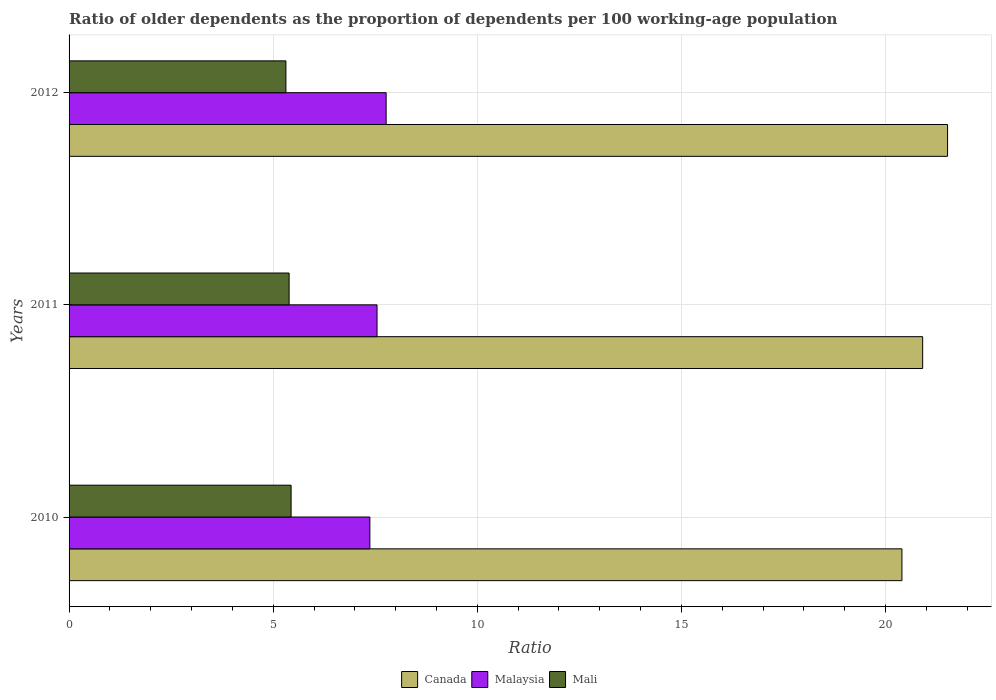How many different coloured bars are there?
Your answer should be very brief. 3. How many groups of bars are there?
Provide a short and direct response. 3. Are the number of bars on each tick of the Y-axis equal?
Provide a succinct answer. Yes. How many bars are there on the 3rd tick from the top?
Make the answer very short. 3. How many bars are there on the 3rd tick from the bottom?
Offer a terse response. 3. What is the label of the 1st group of bars from the top?
Your answer should be very brief. 2012. What is the age dependency ratio(old) in Malaysia in 2012?
Offer a terse response. 7.77. Across all years, what is the maximum age dependency ratio(old) in Mali?
Give a very brief answer. 5.44. Across all years, what is the minimum age dependency ratio(old) in Mali?
Offer a terse response. 5.31. In which year was the age dependency ratio(old) in Canada maximum?
Keep it short and to the point. 2012. In which year was the age dependency ratio(old) in Canada minimum?
Your answer should be very brief. 2010. What is the total age dependency ratio(old) in Mali in the graph?
Offer a terse response. 16.14. What is the difference between the age dependency ratio(old) in Mali in 2010 and that in 2011?
Offer a very short reply. 0.05. What is the difference between the age dependency ratio(old) in Malaysia in 2010 and the age dependency ratio(old) in Canada in 2011?
Provide a succinct answer. -13.54. What is the average age dependency ratio(old) in Malaysia per year?
Offer a very short reply. 7.56. In the year 2012, what is the difference between the age dependency ratio(old) in Canada and age dependency ratio(old) in Malaysia?
Keep it short and to the point. 13.75. What is the ratio of the age dependency ratio(old) in Malaysia in 2010 to that in 2011?
Offer a terse response. 0.98. Is the age dependency ratio(old) in Mali in 2010 less than that in 2012?
Your answer should be compact. No. What is the difference between the highest and the second highest age dependency ratio(old) in Canada?
Your answer should be compact. 0.61. What is the difference between the highest and the lowest age dependency ratio(old) in Malaysia?
Make the answer very short. 0.4. What does the 3rd bar from the bottom in 2011 represents?
Provide a short and direct response. Mali. How many bars are there?
Your answer should be very brief. 9. Are all the bars in the graph horizontal?
Make the answer very short. Yes. How many legend labels are there?
Provide a short and direct response. 3. How are the legend labels stacked?
Your answer should be very brief. Horizontal. What is the title of the graph?
Offer a terse response. Ratio of older dependents as the proportion of dependents per 100 working-age population. Does "Bhutan" appear as one of the legend labels in the graph?
Provide a succinct answer. No. What is the label or title of the X-axis?
Your response must be concise. Ratio. What is the label or title of the Y-axis?
Provide a succinct answer. Years. What is the Ratio in Canada in 2010?
Give a very brief answer. 20.4. What is the Ratio in Malaysia in 2010?
Provide a succinct answer. 7.37. What is the Ratio of Mali in 2010?
Provide a succinct answer. 5.44. What is the Ratio of Canada in 2011?
Your response must be concise. 20.91. What is the Ratio in Malaysia in 2011?
Make the answer very short. 7.54. What is the Ratio in Mali in 2011?
Offer a very short reply. 5.39. What is the Ratio in Canada in 2012?
Your response must be concise. 21.52. What is the Ratio in Malaysia in 2012?
Provide a succinct answer. 7.77. What is the Ratio in Mali in 2012?
Offer a very short reply. 5.31. Across all years, what is the maximum Ratio of Canada?
Offer a very short reply. 21.52. Across all years, what is the maximum Ratio of Malaysia?
Ensure brevity in your answer.  7.77. Across all years, what is the maximum Ratio of Mali?
Your answer should be compact. 5.44. Across all years, what is the minimum Ratio of Canada?
Provide a succinct answer. 20.4. Across all years, what is the minimum Ratio of Malaysia?
Make the answer very short. 7.37. Across all years, what is the minimum Ratio of Mali?
Offer a terse response. 5.31. What is the total Ratio in Canada in the graph?
Offer a terse response. 62.83. What is the total Ratio in Malaysia in the graph?
Keep it short and to the point. 22.68. What is the total Ratio of Mali in the graph?
Provide a succinct answer. 16.14. What is the difference between the Ratio in Canada in 2010 and that in 2011?
Ensure brevity in your answer.  -0.51. What is the difference between the Ratio in Malaysia in 2010 and that in 2011?
Provide a succinct answer. -0.18. What is the difference between the Ratio of Mali in 2010 and that in 2011?
Your response must be concise. 0.05. What is the difference between the Ratio in Canada in 2010 and that in 2012?
Give a very brief answer. -1.12. What is the difference between the Ratio in Malaysia in 2010 and that in 2012?
Your answer should be compact. -0.4. What is the difference between the Ratio in Mali in 2010 and that in 2012?
Your response must be concise. 0.13. What is the difference between the Ratio in Canada in 2011 and that in 2012?
Give a very brief answer. -0.61. What is the difference between the Ratio of Malaysia in 2011 and that in 2012?
Give a very brief answer. -0.22. What is the difference between the Ratio of Mali in 2011 and that in 2012?
Ensure brevity in your answer.  0.08. What is the difference between the Ratio of Canada in 2010 and the Ratio of Malaysia in 2011?
Make the answer very short. 12.86. What is the difference between the Ratio in Canada in 2010 and the Ratio in Mali in 2011?
Your answer should be compact. 15.01. What is the difference between the Ratio of Malaysia in 2010 and the Ratio of Mali in 2011?
Your response must be concise. 1.98. What is the difference between the Ratio of Canada in 2010 and the Ratio of Malaysia in 2012?
Your response must be concise. 12.63. What is the difference between the Ratio in Canada in 2010 and the Ratio in Mali in 2012?
Offer a very short reply. 15.09. What is the difference between the Ratio of Malaysia in 2010 and the Ratio of Mali in 2012?
Offer a very short reply. 2.06. What is the difference between the Ratio in Canada in 2011 and the Ratio in Malaysia in 2012?
Offer a terse response. 13.14. What is the difference between the Ratio of Canada in 2011 and the Ratio of Mali in 2012?
Your response must be concise. 15.6. What is the difference between the Ratio of Malaysia in 2011 and the Ratio of Mali in 2012?
Make the answer very short. 2.23. What is the average Ratio in Canada per year?
Provide a short and direct response. 20.94. What is the average Ratio of Malaysia per year?
Provide a succinct answer. 7.56. What is the average Ratio of Mali per year?
Give a very brief answer. 5.38. In the year 2010, what is the difference between the Ratio of Canada and Ratio of Malaysia?
Your answer should be very brief. 13.03. In the year 2010, what is the difference between the Ratio of Canada and Ratio of Mali?
Ensure brevity in your answer.  14.96. In the year 2010, what is the difference between the Ratio of Malaysia and Ratio of Mali?
Your response must be concise. 1.93. In the year 2011, what is the difference between the Ratio of Canada and Ratio of Malaysia?
Keep it short and to the point. 13.37. In the year 2011, what is the difference between the Ratio in Canada and Ratio in Mali?
Provide a short and direct response. 15.52. In the year 2011, what is the difference between the Ratio of Malaysia and Ratio of Mali?
Your answer should be very brief. 2.15. In the year 2012, what is the difference between the Ratio in Canada and Ratio in Malaysia?
Give a very brief answer. 13.75. In the year 2012, what is the difference between the Ratio in Canada and Ratio in Mali?
Your answer should be very brief. 16.21. In the year 2012, what is the difference between the Ratio of Malaysia and Ratio of Mali?
Provide a succinct answer. 2.46. What is the ratio of the Ratio of Canada in 2010 to that in 2011?
Ensure brevity in your answer.  0.98. What is the ratio of the Ratio of Malaysia in 2010 to that in 2011?
Offer a very short reply. 0.98. What is the ratio of the Ratio of Mali in 2010 to that in 2011?
Offer a terse response. 1.01. What is the ratio of the Ratio in Canada in 2010 to that in 2012?
Ensure brevity in your answer.  0.95. What is the ratio of the Ratio of Malaysia in 2010 to that in 2012?
Offer a terse response. 0.95. What is the ratio of the Ratio in Mali in 2010 to that in 2012?
Your answer should be very brief. 1.02. What is the ratio of the Ratio in Canada in 2011 to that in 2012?
Offer a very short reply. 0.97. What is the ratio of the Ratio in Malaysia in 2011 to that in 2012?
Make the answer very short. 0.97. What is the ratio of the Ratio of Mali in 2011 to that in 2012?
Provide a succinct answer. 1.01. What is the difference between the highest and the second highest Ratio in Canada?
Provide a short and direct response. 0.61. What is the difference between the highest and the second highest Ratio in Malaysia?
Keep it short and to the point. 0.22. What is the difference between the highest and the second highest Ratio of Mali?
Provide a succinct answer. 0.05. What is the difference between the highest and the lowest Ratio of Canada?
Offer a terse response. 1.12. What is the difference between the highest and the lowest Ratio of Malaysia?
Keep it short and to the point. 0.4. What is the difference between the highest and the lowest Ratio of Mali?
Offer a very short reply. 0.13. 